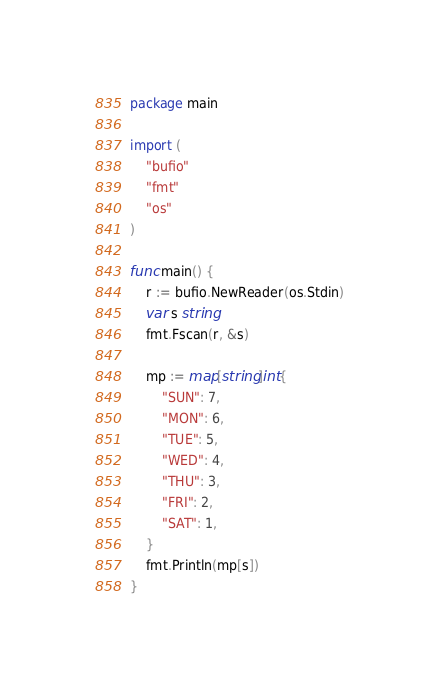Convert code to text. <code><loc_0><loc_0><loc_500><loc_500><_Go_>package main

import (
	"bufio"
	"fmt"
	"os"
)

func main() {
	r := bufio.NewReader(os.Stdin)
	var s string
	fmt.Fscan(r, &s)

	mp := map[string]int{
		"SUN": 7,
		"MON": 6,
		"TUE": 5,
		"WED": 4,
		"THU": 3,
		"FRI": 2,
		"SAT": 1,
	}
	fmt.Println(mp[s])
}</code> 